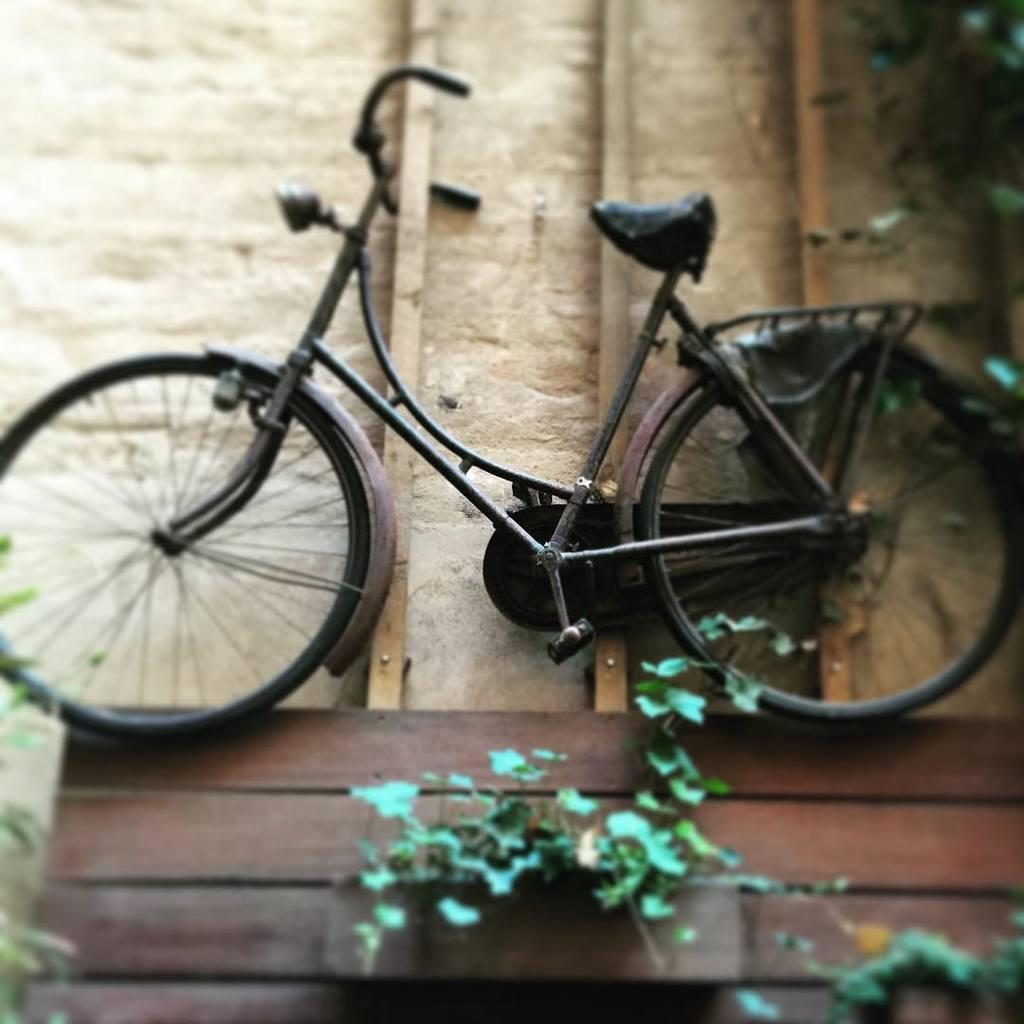What is the main object in the image? There is a table in the image. What is placed on the table? There is a toy cycle on the table. What type of pain is the toy cycle experiencing in the image? The toy cycle is not a living being and therefore cannot experience pain. 